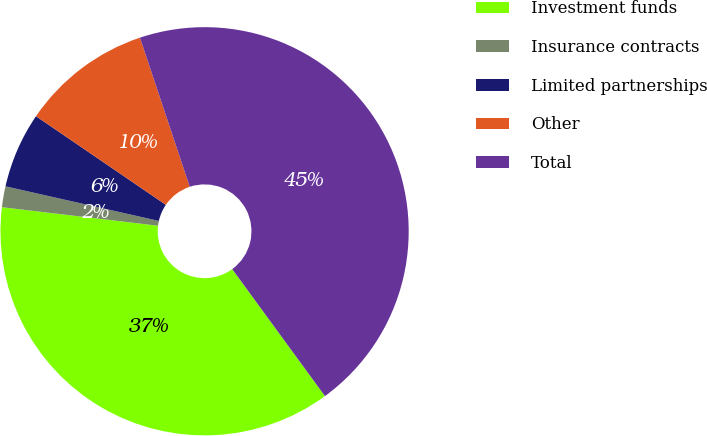Convert chart. <chart><loc_0><loc_0><loc_500><loc_500><pie_chart><fcel>Investment funds<fcel>Insurance contracts<fcel>Limited partnerships<fcel>Other<fcel>Total<nl><fcel>36.92%<fcel>1.65%<fcel>6.0%<fcel>10.34%<fcel>45.09%<nl></chart> 